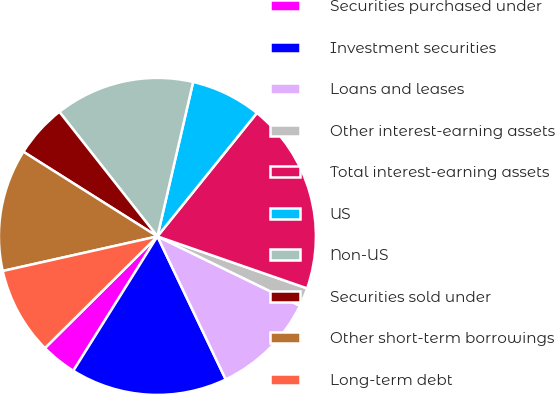<chart> <loc_0><loc_0><loc_500><loc_500><pie_chart><fcel>Securities purchased under<fcel>Investment securities<fcel>Loans and leases<fcel>Other interest-earning assets<fcel>Total interest-earning assets<fcel>US<fcel>Non-US<fcel>Securities sold under<fcel>Other short-term borrowings<fcel>Long-term debt<nl><fcel>3.66%<fcel>15.99%<fcel>10.7%<fcel>1.89%<fcel>19.52%<fcel>7.18%<fcel>14.23%<fcel>5.42%<fcel>12.47%<fcel>8.94%<nl></chart> 